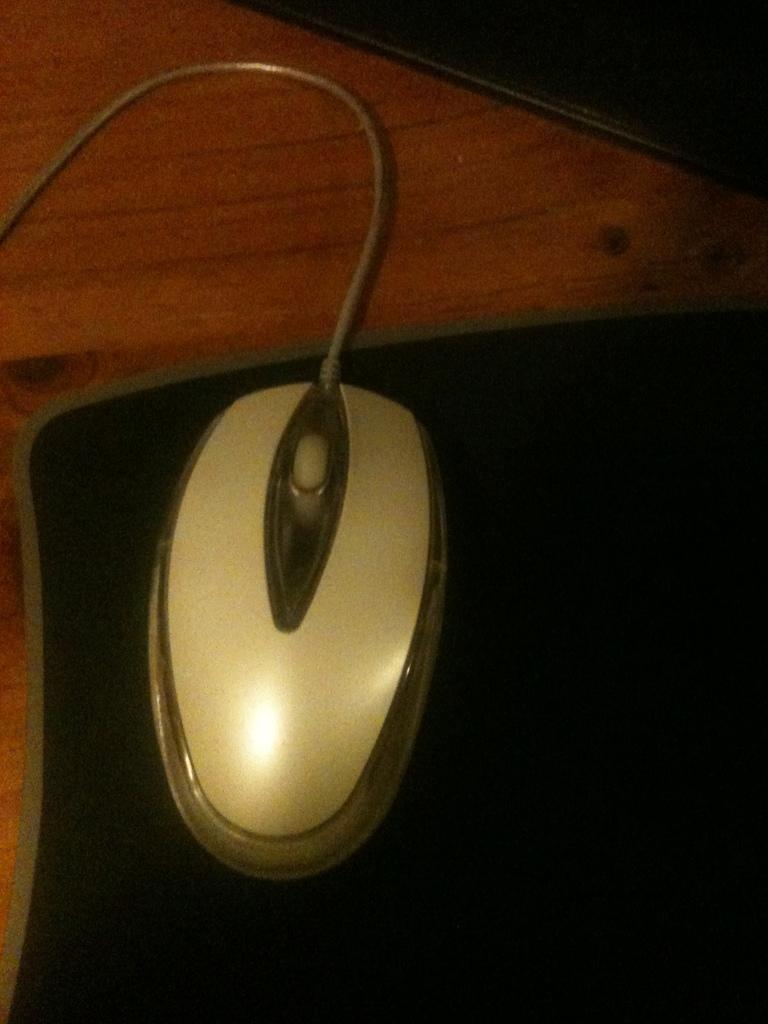Describe this image in one or two sentences. It is a mouse on the mouse pad. 